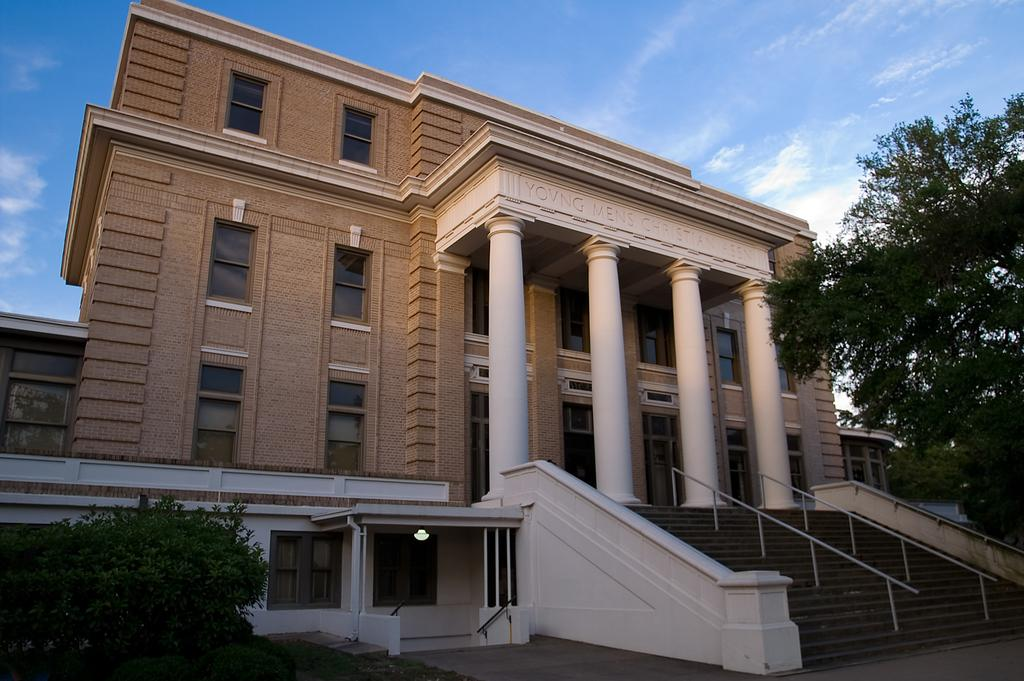What type of natural elements can be seen in the image? There are trees in the image. What type of man-made structure is present in the image? There is a building in the image. What type of artificial light source is visible in the image? There is a light in the image. What can be seen in the background of the image? The sky is visible in the background of the image. What type of weather condition can be inferred from the image? There are clouds in the sky, which suggests a partly cloudy or overcast day. What type of hat is the cloud wearing in the image? There are no hats present in the image, as clouds are natural formations and do not wear clothing. What type of spark can be seen coming from the building in the image? There is no spark visible in the image; the light source mentioned is not described as sparking. 